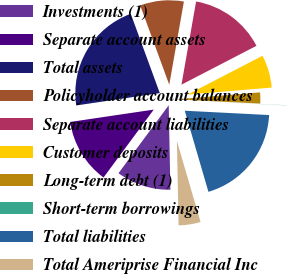Convert chart. <chart><loc_0><loc_0><loc_500><loc_500><pie_chart><fcel>Investments (1)<fcel>Separate account assets<fcel>Total assets<fcel>Policyholder account balances<fcel>Separate account liabilities<fcel>Customer deposits<fcel>Long-term debt (1)<fcel>Short-term borrowings<fcel>Total liabilities<fcel>Total Ameriprise Financial Inc<nl><fcel>10.45%<fcel>12.53%<fcel>21.75%<fcel>8.36%<fcel>14.62%<fcel>6.28%<fcel>2.11%<fcel>0.03%<fcel>19.67%<fcel>4.2%<nl></chart> 